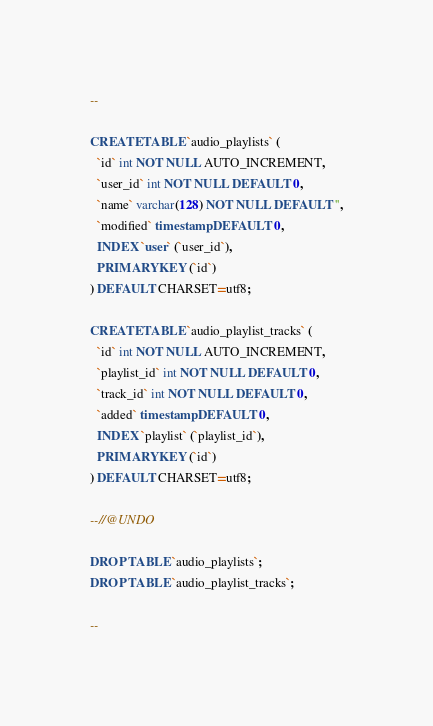Convert code to text. <code><loc_0><loc_0><loc_500><loc_500><_SQL_>--

CREATE TABLE `audio_playlists` (
  `id` int NOT NULL AUTO_INCREMENT,
  `user_id` int NOT NULL DEFAULT 0,
  `name` varchar(128) NOT NULL DEFAULT '',
  `modified` timestamp DEFAULT 0,
  INDEX `user` (`user_id`),
  PRIMARY KEY (`id`)
) DEFAULT CHARSET=utf8;

CREATE TABLE `audio_playlist_tracks` (
  `id` int NOT NULL AUTO_INCREMENT,
  `playlist_id` int NOT NULL DEFAULT 0,
  `track_id` int NOT NULL DEFAULT 0,
  `added` timestamp DEFAULT 0,
  INDEX `playlist` (`playlist_id`),
  PRIMARY KEY (`id`)
) DEFAULT CHARSET=utf8;

--//@UNDO

DROP TABLE `audio_playlists`;
DROP TABLE `audio_playlist_tracks`;

--</code> 